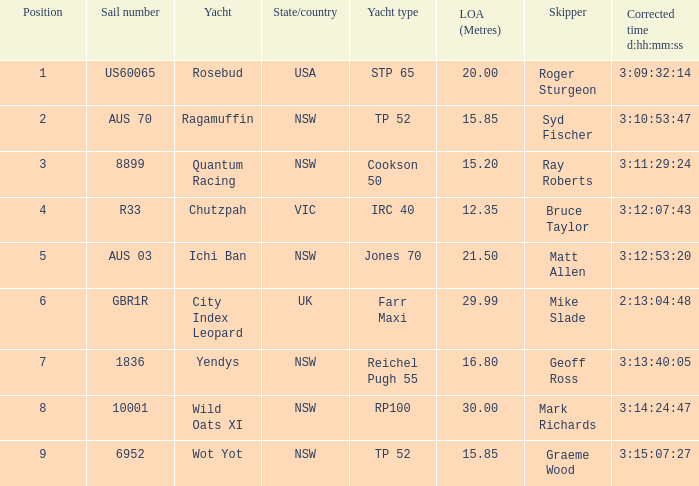Who were all the captains with an adjusted time of 3:15:07:27? Graeme Wood. 